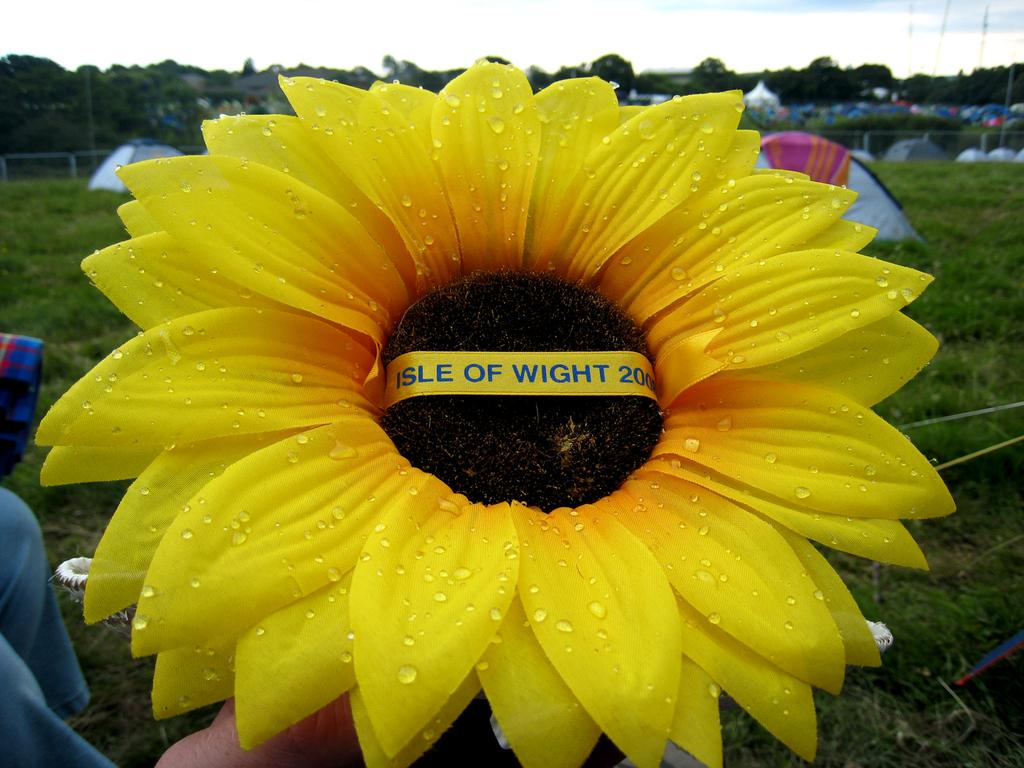What is the person in the image holding? The person is holding a flower in the image. What can be seen in the background of the image? There are tents, grass, a fence, trees, and the sky visible in the background of the image. What is the condition of the sky in the image? The sky appears cloudy in the image. What type of sign can be seen in the image? There is no sign present in the image. What type of wood is used to construct the fence in the image? There is no information about the type of wood used to construct the fence in the image. 